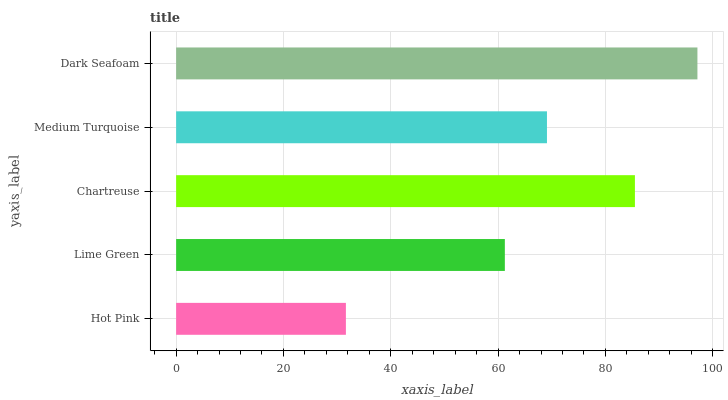Is Hot Pink the minimum?
Answer yes or no. Yes. Is Dark Seafoam the maximum?
Answer yes or no. Yes. Is Lime Green the minimum?
Answer yes or no. No. Is Lime Green the maximum?
Answer yes or no. No. Is Lime Green greater than Hot Pink?
Answer yes or no. Yes. Is Hot Pink less than Lime Green?
Answer yes or no. Yes. Is Hot Pink greater than Lime Green?
Answer yes or no. No. Is Lime Green less than Hot Pink?
Answer yes or no. No. Is Medium Turquoise the high median?
Answer yes or no. Yes. Is Medium Turquoise the low median?
Answer yes or no. Yes. Is Dark Seafoam the high median?
Answer yes or no. No. Is Dark Seafoam the low median?
Answer yes or no. No. 